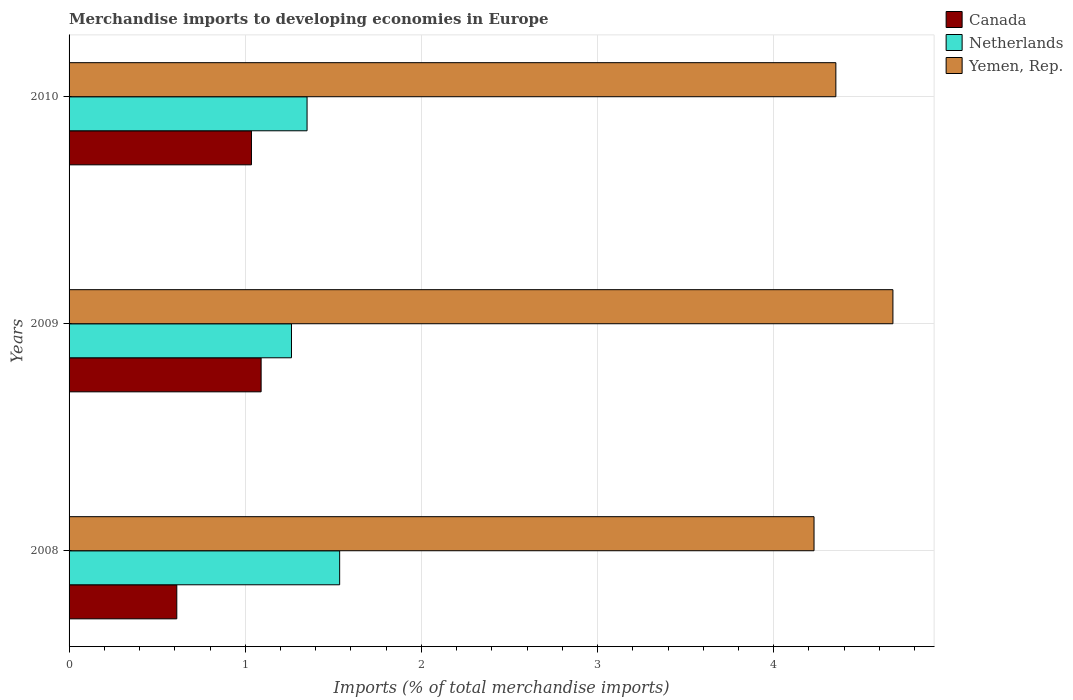How many different coloured bars are there?
Your answer should be compact. 3. Are the number of bars per tick equal to the number of legend labels?
Offer a terse response. Yes. How many bars are there on the 2nd tick from the top?
Your response must be concise. 3. What is the label of the 1st group of bars from the top?
Your answer should be compact. 2010. In how many cases, is the number of bars for a given year not equal to the number of legend labels?
Provide a succinct answer. 0. What is the percentage total merchandise imports in Netherlands in 2008?
Provide a succinct answer. 1.54. Across all years, what is the maximum percentage total merchandise imports in Yemen, Rep.?
Offer a terse response. 4.68. Across all years, what is the minimum percentage total merchandise imports in Netherlands?
Your answer should be very brief. 1.26. In which year was the percentage total merchandise imports in Canada minimum?
Make the answer very short. 2008. What is the total percentage total merchandise imports in Canada in the graph?
Offer a very short reply. 2.74. What is the difference between the percentage total merchandise imports in Canada in 2008 and that in 2009?
Keep it short and to the point. -0.48. What is the difference between the percentage total merchandise imports in Yemen, Rep. in 2010 and the percentage total merchandise imports in Netherlands in 2009?
Offer a very short reply. 3.09. What is the average percentage total merchandise imports in Canada per year?
Your response must be concise. 0.91. In the year 2010, what is the difference between the percentage total merchandise imports in Canada and percentage total merchandise imports in Netherlands?
Provide a succinct answer. -0.32. What is the ratio of the percentage total merchandise imports in Canada in 2009 to that in 2010?
Make the answer very short. 1.05. Is the percentage total merchandise imports in Yemen, Rep. in 2009 less than that in 2010?
Ensure brevity in your answer.  No. What is the difference between the highest and the second highest percentage total merchandise imports in Canada?
Provide a succinct answer. 0.05. What is the difference between the highest and the lowest percentage total merchandise imports in Netherlands?
Give a very brief answer. 0.27. In how many years, is the percentage total merchandise imports in Netherlands greater than the average percentage total merchandise imports in Netherlands taken over all years?
Give a very brief answer. 1. What does the 1st bar from the top in 2009 represents?
Ensure brevity in your answer.  Yemen, Rep. How many years are there in the graph?
Offer a very short reply. 3. Are the values on the major ticks of X-axis written in scientific E-notation?
Your response must be concise. No. Does the graph contain any zero values?
Offer a terse response. No. Where does the legend appear in the graph?
Your answer should be very brief. Top right. How are the legend labels stacked?
Your response must be concise. Vertical. What is the title of the graph?
Your answer should be compact. Merchandise imports to developing economies in Europe. Does "High income" appear as one of the legend labels in the graph?
Offer a terse response. No. What is the label or title of the X-axis?
Offer a terse response. Imports (% of total merchandise imports). What is the Imports (% of total merchandise imports) of Canada in 2008?
Provide a short and direct response. 0.61. What is the Imports (% of total merchandise imports) in Netherlands in 2008?
Make the answer very short. 1.54. What is the Imports (% of total merchandise imports) in Yemen, Rep. in 2008?
Offer a terse response. 4.23. What is the Imports (% of total merchandise imports) of Canada in 2009?
Your answer should be compact. 1.09. What is the Imports (% of total merchandise imports) in Netherlands in 2009?
Give a very brief answer. 1.26. What is the Imports (% of total merchandise imports) in Yemen, Rep. in 2009?
Offer a terse response. 4.68. What is the Imports (% of total merchandise imports) in Canada in 2010?
Provide a short and direct response. 1.04. What is the Imports (% of total merchandise imports) in Netherlands in 2010?
Your answer should be very brief. 1.35. What is the Imports (% of total merchandise imports) of Yemen, Rep. in 2010?
Provide a succinct answer. 4.35. Across all years, what is the maximum Imports (% of total merchandise imports) of Canada?
Your answer should be compact. 1.09. Across all years, what is the maximum Imports (% of total merchandise imports) of Netherlands?
Give a very brief answer. 1.54. Across all years, what is the maximum Imports (% of total merchandise imports) in Yemen, Rep.?
Ensure brevity in your answer.  4.68. Across all years, what is the minimum Imports (% of total merchandise imports) of Canada?
Ensure brevity in your answer.  0.61. Across all years, what is the minimum Imports (% of total merchandise imports) of Netherlands?
Offer a very short reply. 1.26. Across all years, what is the minimum Imports (% of total merchandise imports) of Yemen, Rep.?
Ensure brevity in your answer.  4.23. What is the total Imports (% of total merchandise imports) of Canada in the graph?
Provide a short and direct response. 2.74. What is the total Imports (% of total merchandise imports) in Netherlands in the graph?
Ensure brevity in your answer.  4.15. What is the total Imports (% of total merchandise imports) in Yemen, Rep. in the graph?
Give a very brief answer. 13.26. What is the difference between the Imports (% of total merchandise imports) of Canada in 2008 and that in 2009?
Your answer should be very brief. -0.48. What is the difference between the Imports (% of total merchandise imports) of Netherlands in 2008 and that in 2009?
Offer a very short reply. 0.27. What is the difference between the Imports (% of total merchandise imports) in Yemen, Rep. in 2008 and that in 2009?
Keep it short and to the point. -0.45. What is the difference between the Imports (% of total merchandise imports) in Canada in 2008 and that in 2010?
Provide a succinct answer. -0.42. What is the difference between the Imports (% of total merchandise imports) in Netherlands in 2008 and that in 2010?
Your response must be concise. 0.18. What is the difference between the Imports (% of total merchandise imports) in Yemen, Rep. in 2008 and that in 2010?
Your response must be concise. -0.12. What is the difference between the Imports (% of total merchandise imports) in Canada in 2009 and that in 2010?
Your answer should be compact. 0.05. What is the difference between the Imports (% of total merchandise imports) of Netherlands in 2009 and that in 2010?
Keep it short and to the point. -0.09. What is the difference between the Imports (% of total merchandise imports) of Yemen, Rep. in 2009 and that in 2010?
Give a very brief answer. 0.32. What is the difference between the Imports (% of total merchandise imports) in Canada in 2008 and the Imports (% of total merchandise imports) in Netherlands in 2009?
Your response must be concise. -0.65. What is the difference between the Imports (% of total merchandise imports) in Canada in 2008 and the Imports (% of total merchandise imports) in Yemen, Rep. in 2009?
Your response must be concise. -4.07. What is the difference between the Imports (% of total merchandise imports) of Netherlands in 2008 and the Imports (% of total merchandise imports) of Yemen, Rep. in 2009?
Ensure brevity in your answer.  -3.14. What is the difference between the Imports (% of total merchandise imports) in Canada in 2008 and the Imports (% of total merchandise imports) in Netherlands in 2010?
Your answer should be very brief. -0.74. What is the difference between the Imports (% of total merchandise imports) of Canada in 2008 and the Imports (% of total merchandise imports) of Yemen, Rep. in 2010?
Keep it short and to the point. -3.74. What is the difference between the Imports (% of total merchandise imports) of Netherlands in 2008 and the Imports (% of total merchandise imports) of Yemen, Rep. in 2010?
Offer a very short reply. -2.82. What is the difference between the Imports (% of total merchandise imports) in Canada in 2009 and the Imports (% of total merchandise imports) in Netherlands in 2010?
Your response must be concise. -0.26. What is the difference between the Imports (% of total merchandise imports) of Canada in 2009 and the Imports (% of total merchandise imports) of Yemen, Rep. in 2010?
Your response must be concise. -3.26. What is the difference between the Imports (% of total merchandise imports) in Netherlands in 2009 and the Imports (% of total merchandise imports) in Yemen, Rep. in 2010?
Offer a terse response. -3.09. What is the average Imports (% of total merchandise imports) in Canada per year?
Give a very brief answer. 0.91. What is the average Imports (% of total merchandise imports) of Netherlands per year?
Keep it short and to the point. 1.38. What is the average Imports (% of total merchandise imports) in Yemen, Rep. per year?
Your response must be concise. 4.42. In the year 2008, what is the difference between the Imports (% of total merchandise imports) of Canada and Imports (% of total merchandise imports) of Netherlands?
Offer a very short reply. -0.92. In the year 2008, what is the difference between the Imports (% of total merchandise imports) in Canada and Imports (% of total merchandise imports) in Yemen, Rep.?
Provide a short and direct response. -3.62. In the year 2008, what is the difference between the Imports (% of total merchandise imports) in Netherlands and Imports (% of total merchandise imports) in Yemen, Rep.?
Keep it short and to the point. -2.69. In the year 2009, what is the difference between the Imports (% of total merchandise imports) of Canada and Imports (% of total merchandise imports) of Netherlands?
Offer a very short reply. -0.17. In the year 2009, what is the difference between the Imports (% of total merchandise imports) of Canada and Imports (% of total merchandise imports) of Yemen, Rep.?
Keep it short and to the point. -3.59. In the year 2009, what is the difference between the Imports (% of total merchandise imports) in Netherlands and Imports (% of total merchandise imports) in Yemen, Rep.?
Provide a short and direct response. -3.41. In the year 2010, what is the difference between the Imports (% of total merchandise imports) in Canada and Imports (% of total merchandise imports) in Netherlands?
Ensure brevity in your answer.  -0.32. In the year 2010, what is the difference between the Imports (% of total merchandise imports) of Canada and Imports (% of total merchandise imports) of Yemen, Rep.?
Make the answer very short. -3.32. In the year 2010, what is the difference between the Imports (% of total merchandise imports) in Netherlands and Imports (% of total merchandise imports) in Yemen, Rep.?
Give a very brief answer. -3. What is the ratio of the Imports (% of total merchandise imports) of Canada in 2008 to that in 2009?
Give a very brief answer. 0.56. What is the ratio of the Imports (% of total merchandise imports) of Netherlands in 2008 to that in 2009?
Offer a very short reply. 1.22. What is the ratio of the Imports (% of total merchandise imports) in Yemen, Rep. in 2008 to that in 2009?
Your answer should be very brief. 0.9. What is the ratio of the Imports (% of total merchandise imports) in Canada in 2008 to that in 2010?
Your answer should be very brief. 0.59. What is the ratio of the Imports (% of total merchandise imports) in Netherlands in 2008 to that in 2010?
Your answer should be compact. 1.14. What is the ratio of the Imports (% of total merchandise imports) in Yemen, Rep. in 2008 to that in 2010?
Give a very brief answer. 0.97. What is the ratio of the Imports (% of total merchandise imports) of Canada in 2009 to that in 2010?
Offer a very short reply. 1.05. What is the ratio of the Imports (% of total merchandise imports) of Netherlands in 2009 to that in 2010?
Ensure brevity in your answer.  0.93. What is the ratio of the Imports (% of total merchandise imports) of Yemen, Rep. in 2009 to that in 2010?
Your answer should be very brief. 1.07. What is the difference between the highest and the second highest Imports (% of total merchandise imports) of Canada?
Keep it short and to the point. 0.05. What is the difference between the highest and the second highest Imports (% of total merchandise imports) in Netherlands?
Offer a terse response. 0.18. What is the difference between the highest and the second highest Imports (% of total merchandise imports) in Yemen, Rep.?
Keep it short and to the point. 0.32. What is the difference between the highest and the lowest Imports (% of total merchandise imports) of Canada?
Provide a succinct answer. 0.48. What is the difference between the highest and the lowest Imports (% of total merchandise imports) of Netherlands?
Offer a very short reply. 0.27. What is the difference between the highest and the lowest Imports (% of total merchandise imports) of Yemen, Rep.?
Offer a terse response. 0.45. 